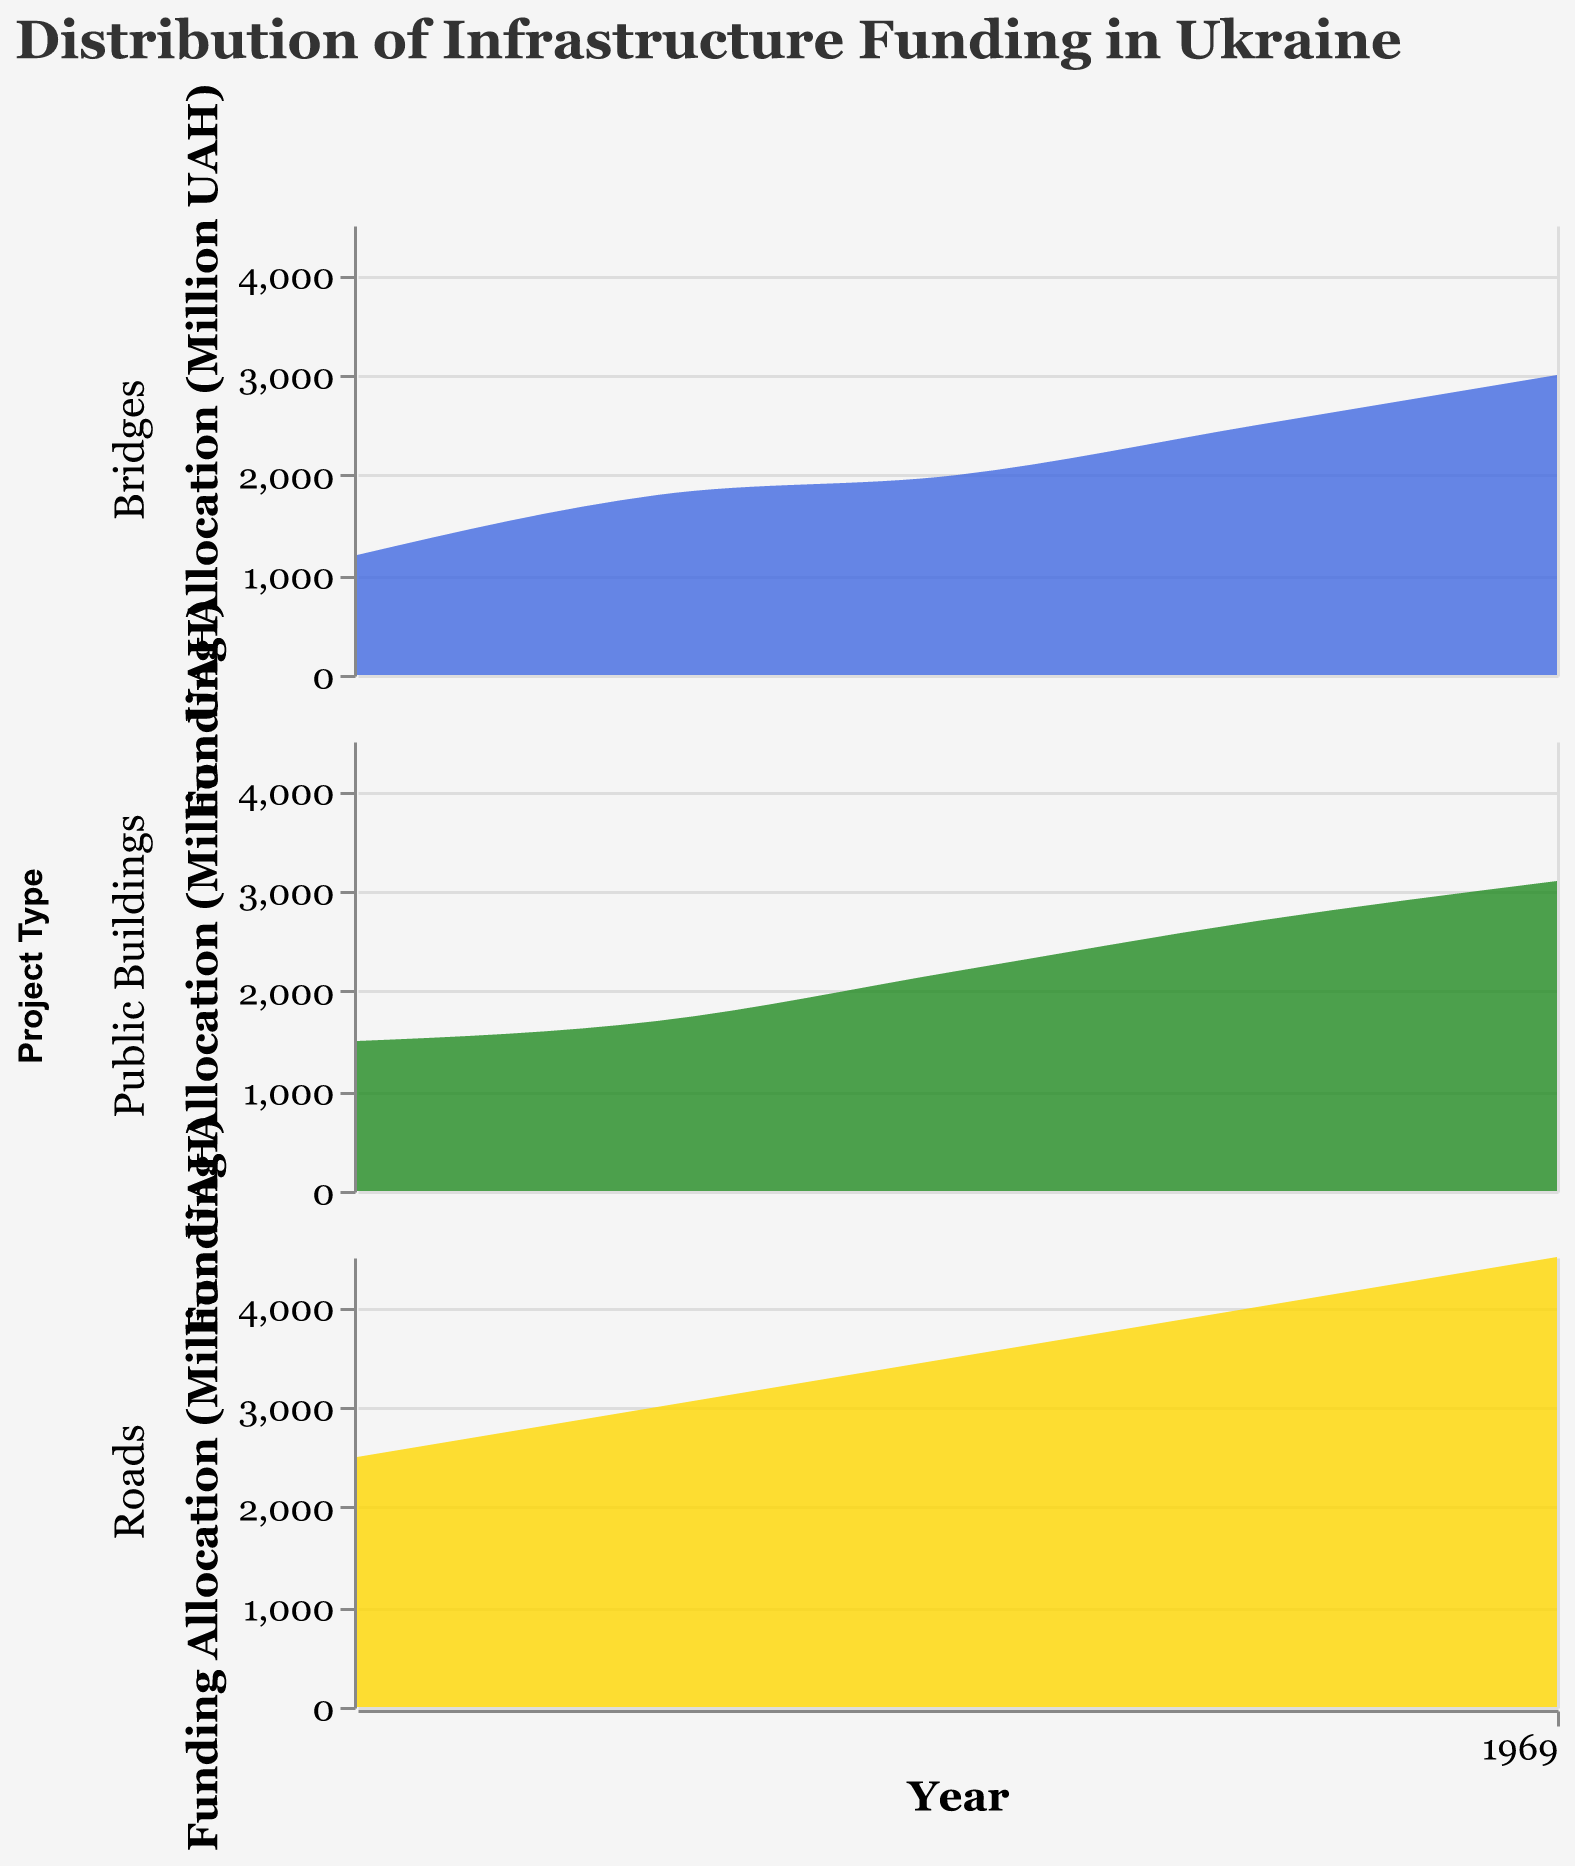What does the title of the figure say? The title text can be found at the top of the figure, which provides a concise summary of what the figure represents.
Answer: Distribution of Infrastructure Funding in Ukraine How many different types of projects are shown in the figure? Each row in the subplot represents a different type of project. By counting the rows, you can determine the number of project types.
Answer: 3 What color represents funding for Bridges? The legend or the color scale on the figure shows which color corresponds to each project type.
Answer: Royal blue During which year did Public Buildings receive the highest funding allocation? By looking at the density plot for Public Buildings and identifying the peak point in the y-axis over time, we can find the year with the highest funding.
Answer: 2020 Compare the funding allocation for Roads and Bridges in 2000. Which one is higher? To compare, look at the density plots for Roads and Bridges in the year 2000 and compare their respective values on the y-axis.
Answer: Roads Between 2005 and 2010, which project type saw the largest increase in funding allocation? For each project type, calculate the increase from 2005 to 2010 by looking at the y-values in both years and finding the difference. Then, compare the increases across project types. Roads saw an increase from 3000 to 3500 Million UAH (500), Bridges from 1800 to 2000 Million UAH (200), and Public Buildings from 1700 to 2200 Million UAH (500). For roads and public buildings, it's the same, so either can be used as the correct answer.
Answer: Roads/Public Buildings What is the total funding allocation for all projects in 2015? Add up the funding allocation for each project type in 2015. Roads = 4000, Bridges = 2500, Public Buildings = 2700. The total is 4000 + 2500 + 2700.
Answer: 9200 Million UAH Was there a consistent increase in funding allocation for Roads from 2000 to 2020? By examining the density plot for Roads from 2000 to 2020 and seeing if there are steady increases in the y-values over time, consistency can be determined.
Answer: Yes Which project type had the smallest funding allocation in 2000? Look at the density plots for 2000 and find the project type with the lowest point on the y-axis.
Answer: Bridges 